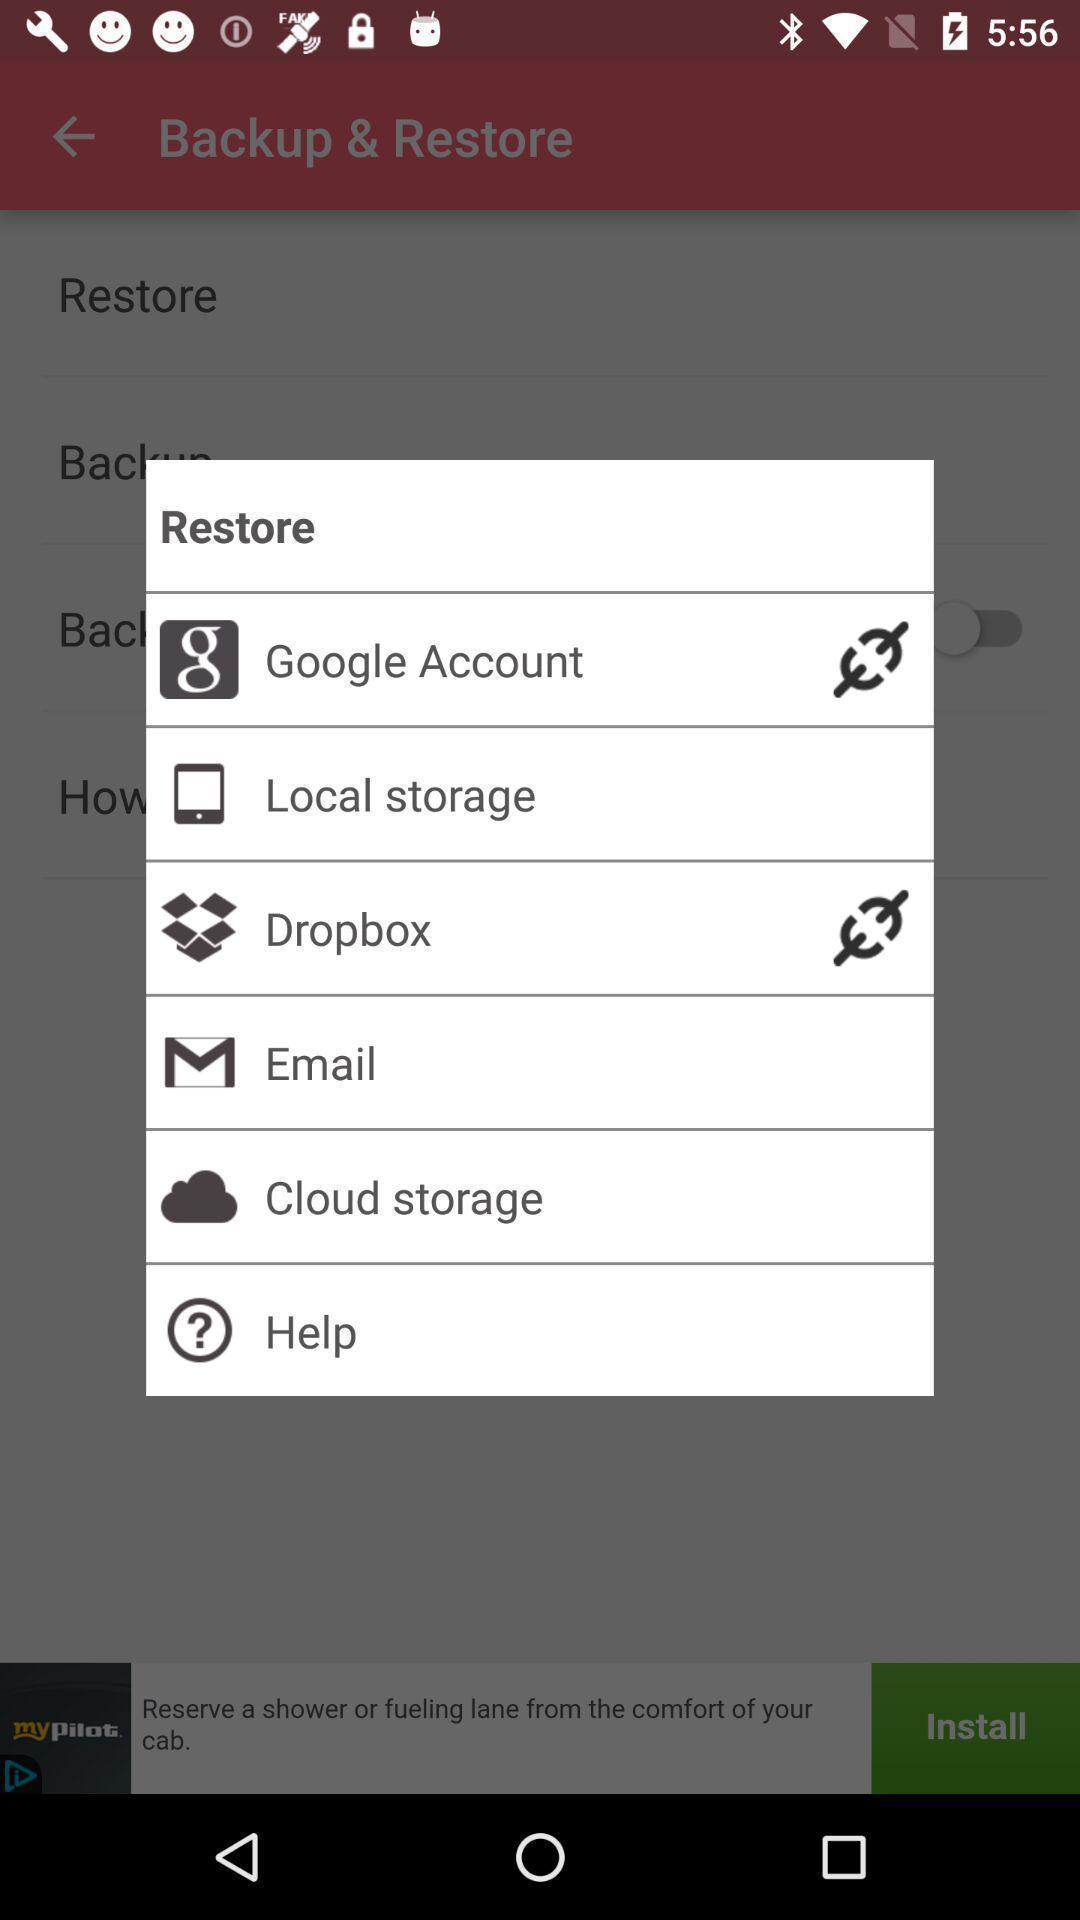Summarize the main components in this picture. Pop-up to restore with different application options. 